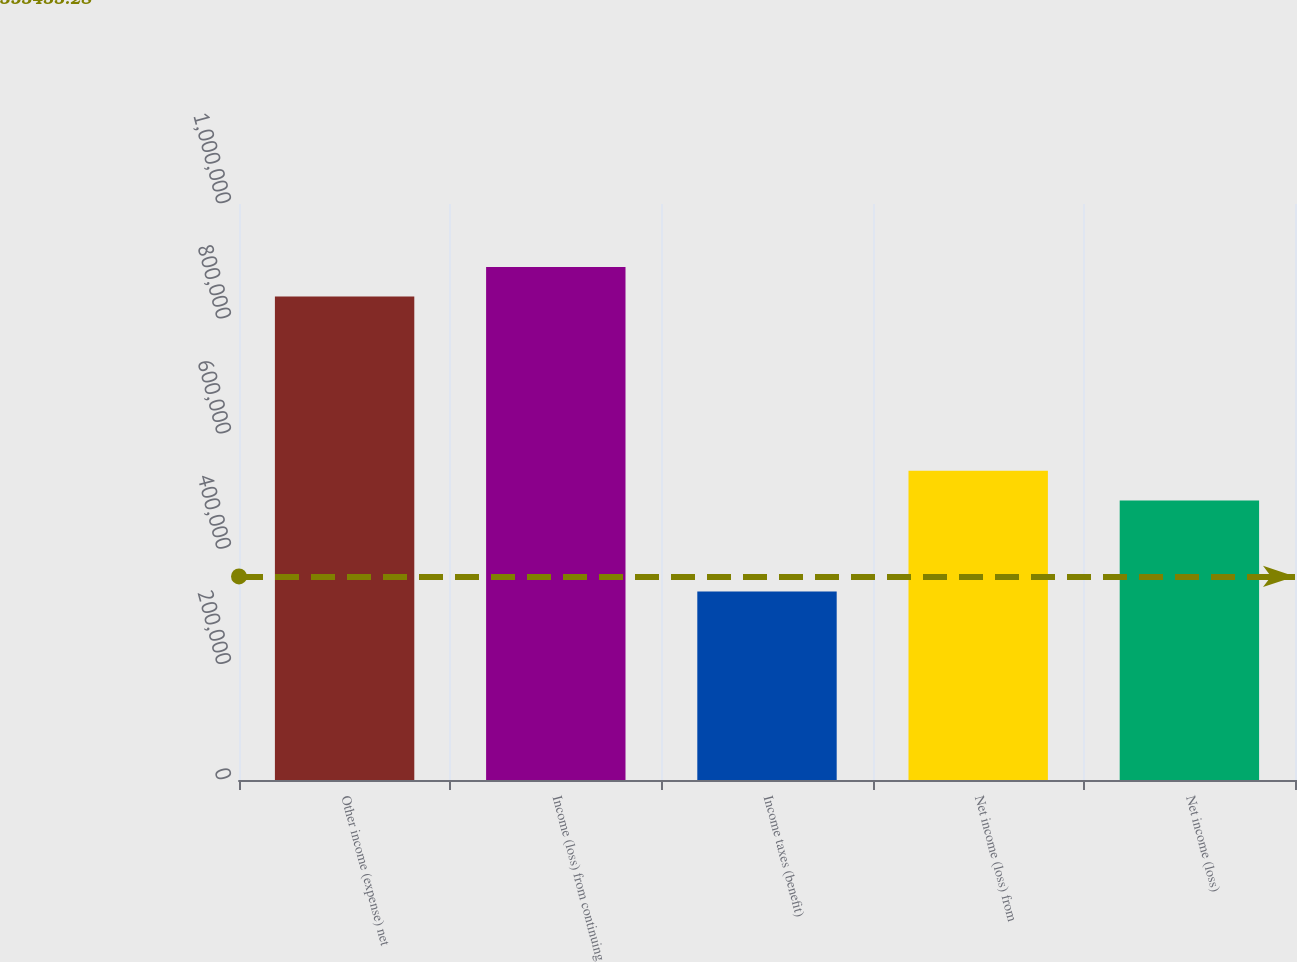Convert chart to OTSL. <chart><loc_0><loc_0><loc_500><loc_500><bar_chart><fcel>Other income (expense) net<fcel>Income (loss) from continuing<fcel>Income taxes (benefit)<fcel>Net income (loss) from<fcel>Net income (loss)<nl><fcel>839338<fcel>890794<fcel>327274<fcel>536843<fcel>485387<nl></chart> 